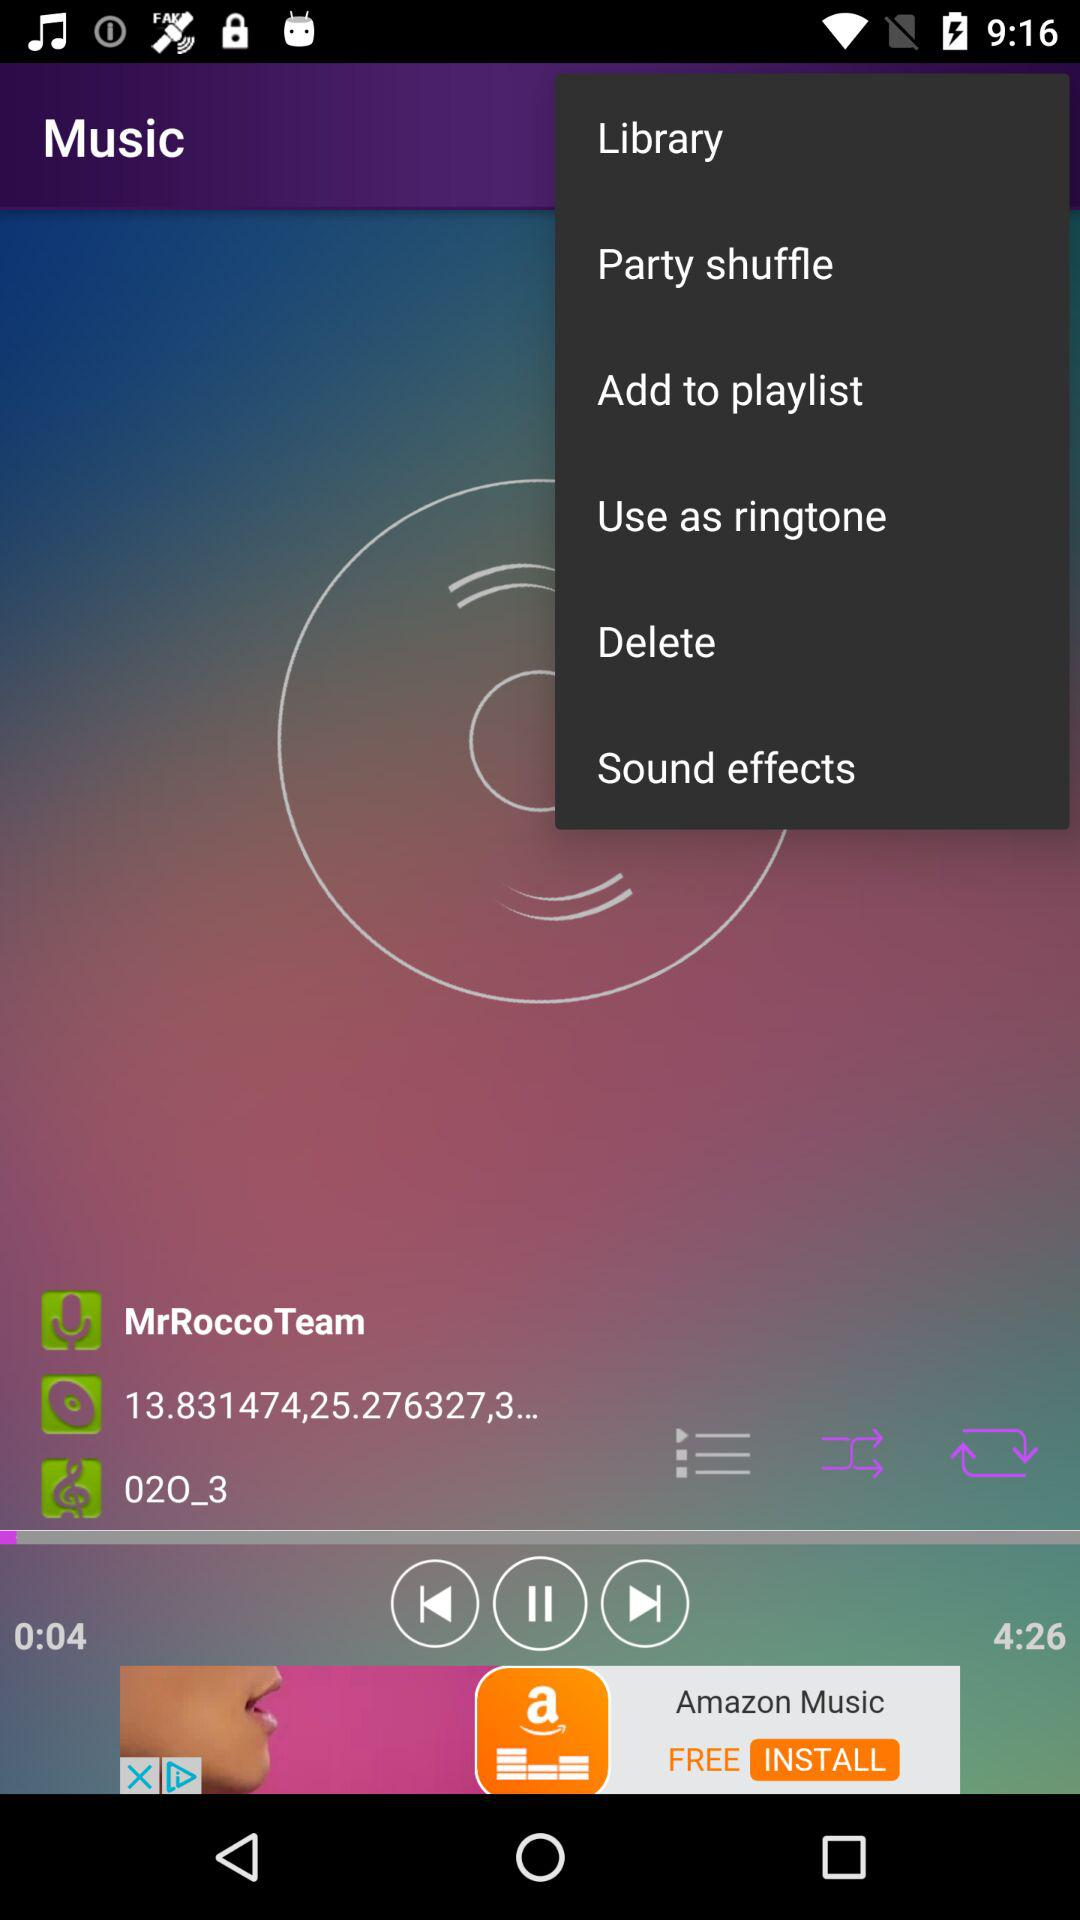For how long has the song been played? The song has been played for 4 seconds. 